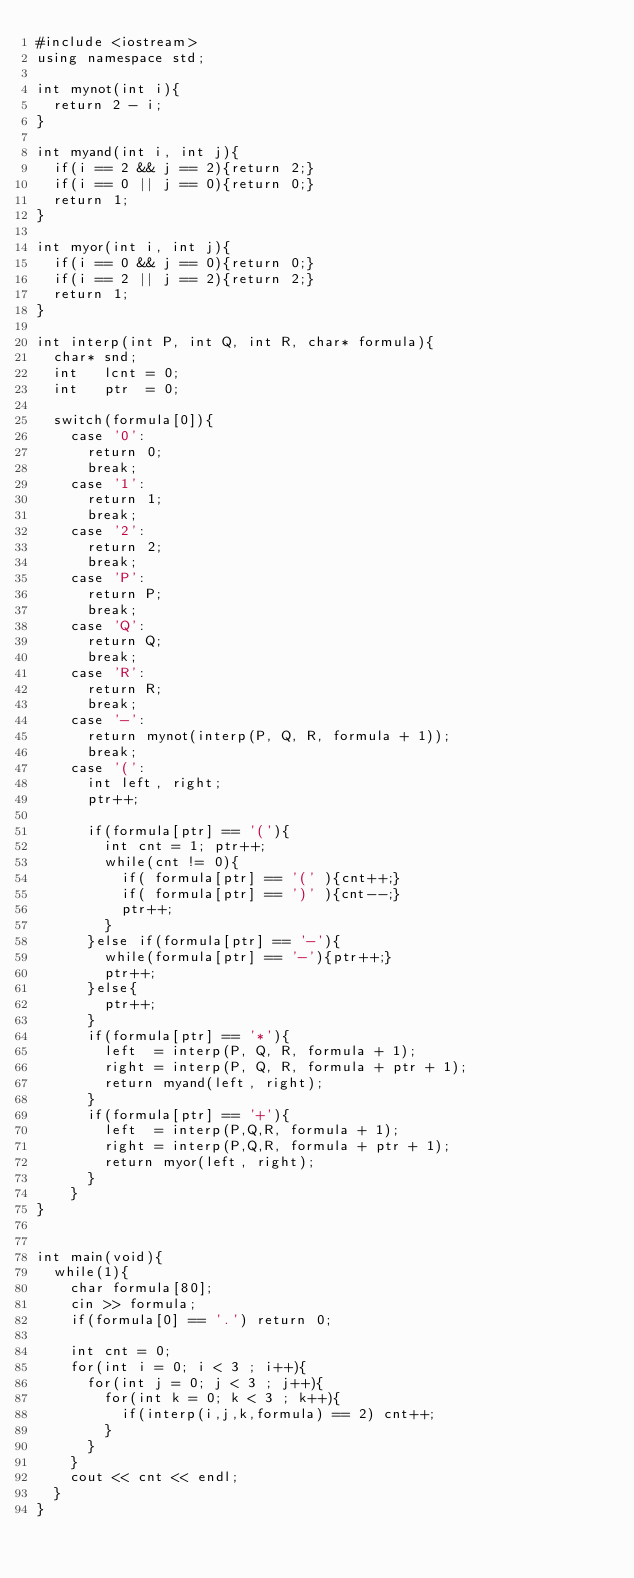<code> <loc_0><loc_0><loc_500><loc_500><_C++_>#include <iostream>
using namespace std;

int mynot(int i){
  return 2 - i;
}

int myand(int i, int j){
  if(i == 2 && j == 2){return 2;}
  if(i == 0 || j == 0){return 0;}
  return 1;
}

int myor(int i, int j){
  if(i == 0 && j == 0){return 0;}
  if(i == 2 || j == 2){return 2;}
  return 1;
}

int interp(int P, int Q, int R, char* formula){
  char* snd;
  int   lcnt = 0;
  int   ptr  = 0;

  switch(formula[0]){
    case '0':
      return 0;
      break;
    case '1':
      return 1;
      break;
    case '2':
      return 2;
      break;
    case 'P':
      return P;
      break;
    case 'Q':
      return Q;
      break;
    case 'R':
      return R;
      break;
    case '-':
      return mynot(interp(P, Q, R, formula + 1));
      break;
    case '(':
      int left, right;
      ptr++;

      if(formula[ptr] == '('){
        int cnt = 1; ptr++;
        while(cnt != 0){
          if( formula[ptr] == '(' ){cnt++;}
          if( formula[ptr] == ')' ){cnt--;}
          ptr++;
        }
      }else if(formula[ptr] == '-'){
        while(formula[ptr] == '-'){ptr++;}
        ptr++;
      }else{
        ptr++;
      }
      if(formula[ptr] == '*'){
        left  = interp(P, Q, R, formula + 1);
        right = interp(P, Q, R, formula + ptr + 1);
        return myand(left, right);
      }
      if(formula[ptr] == '+'){
        left  = interp(P,Q,R, formula + 1);
        right = interp(P,Q,R, formula + ptr + 1);
        return myor(left, right);
      }
    }
}


int main(void){
  while(1){
    char formula[80];
    cin >> formula;
    if(formula[0] == '.') return 0;

    int cnt = 0;
    for(int i = 0; i < 3 ; i++){
      for(int j = 0; j < 3 ; j++){
        for(int k = 0; k < 3 ; k++){
          if(interp(i,j,k,formula) == 2) cnt++;
        }
      }
    }
    cout << cnt << endl;
  }
}</code> 